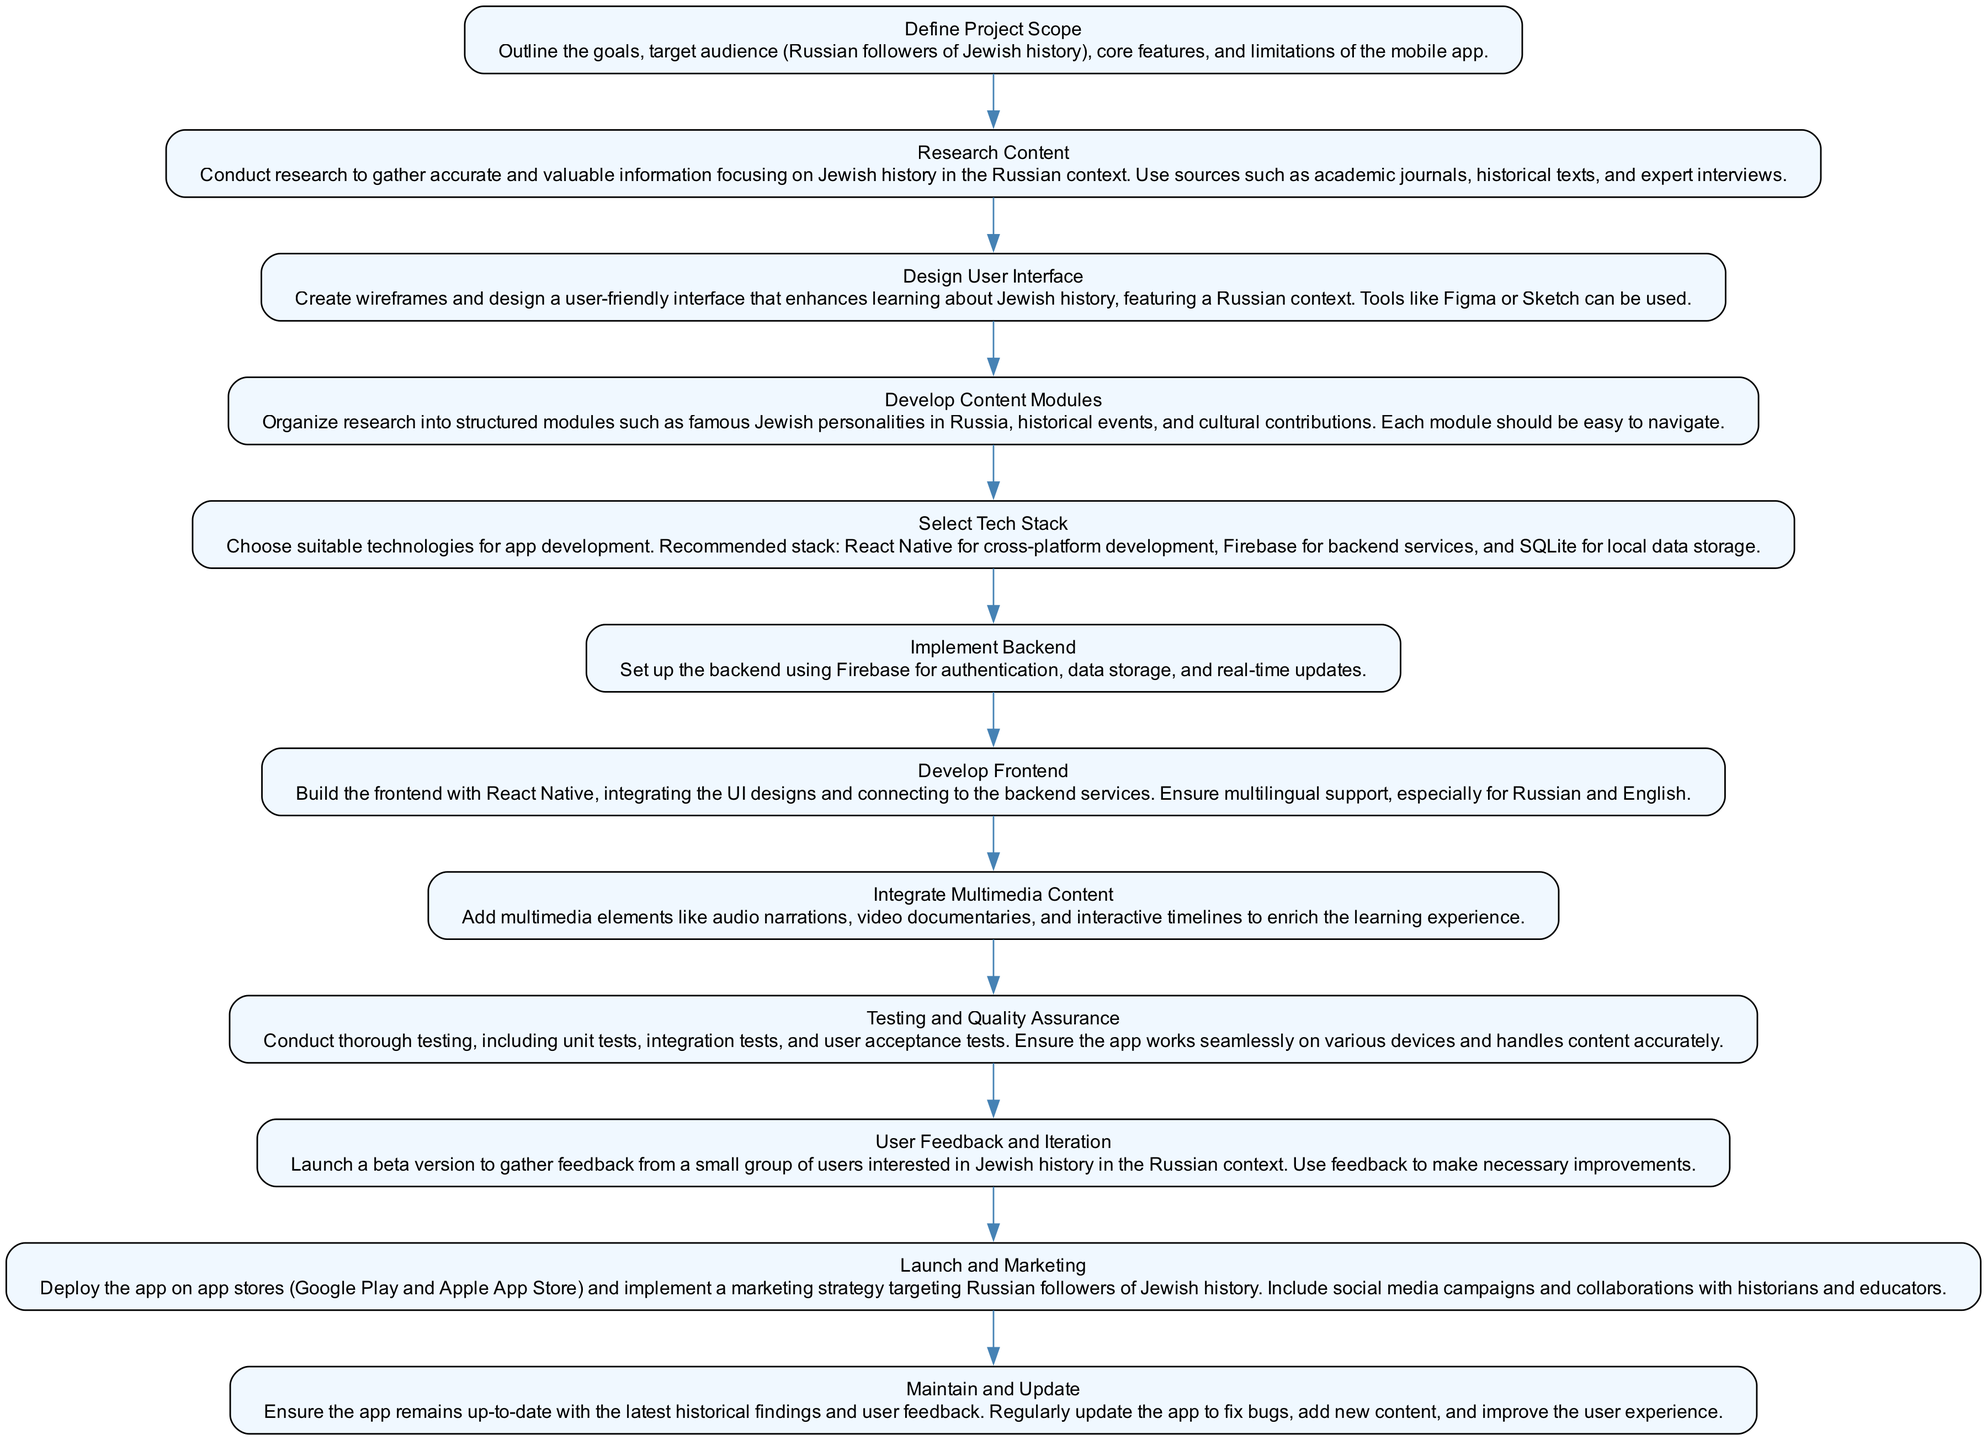What is the first step in the development process? The diagram indicates that the first step is to "Define Project Scope." This is the initial action taken before any other steps are followed.
Answer: Define Project Scope How many nodes are in the flowchart? The diagram contains a total of twelve nodes, each representing a different step in the mobile app development process.
Answer: 12 What technology is recommended for backend services? The flowchart describes "Firebase" as the recommended technology for backend services, which provides authentication and data storage.
Answer: Firebase Which step immediately follows "Research Content"? According to the flowchart, the step that follows "Research Content" is "Design User Interface." This connection indicates a sequential flow in the development process.
Answer: Design User Interface What module focuses on historical figures? The flowchart specifies that the "Develop Content Modules" step includes a module that focuses on "famous Jewish personalities in Russia," pointing to its educational theme.
Answer: Famous Jewish personalities in Russia What is the primary goal of the "User Feedback and Iteration" step? This step aims to gather insights from a small group of users to improve the app, indicating its focus on user experience and satisfaction.
Answer: Gather feedback How does the inclusion of multimedia content enhance learning? The "Integrate Multimedia Content" step indicates that adding audio, video, and interactive elements enriches the educational experience for users learning Jewish history.
Answer: Enrich the learning experience What is the final step in the flowchart? The flowchart concludes with the "Maintain and Update" step, emphasizing ongoing support and improvements to the app after its launch.
Answer: Maintain and Update What important aspect should be ensured during "Testing and Quality Assurance"? The flowchart stresses that the app must work seamlessly on various devices, highlighting the need for compatibility and reliability.
Answer: Compatibility and reliability 